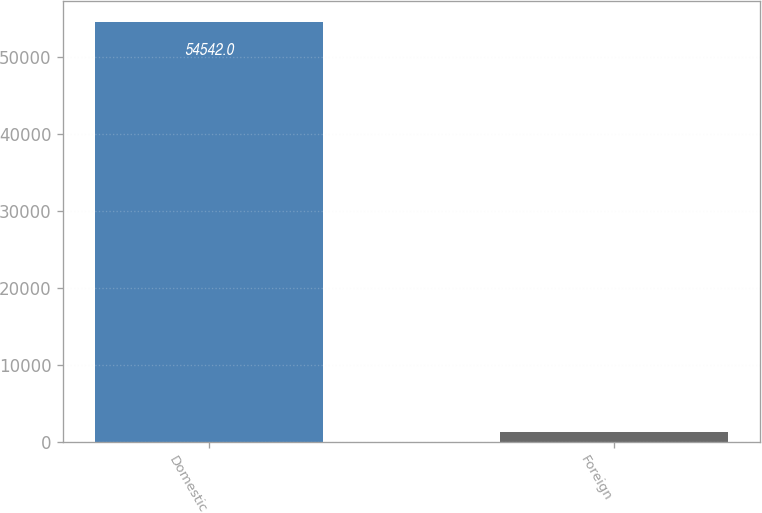Convert chart. <chart><loc_0><loc_0><loc_500><loc_500><bar_chart><fcel>Domestic<fcel>Foreign<nl><fcel>54542<fcel>1319<nl></chart> 